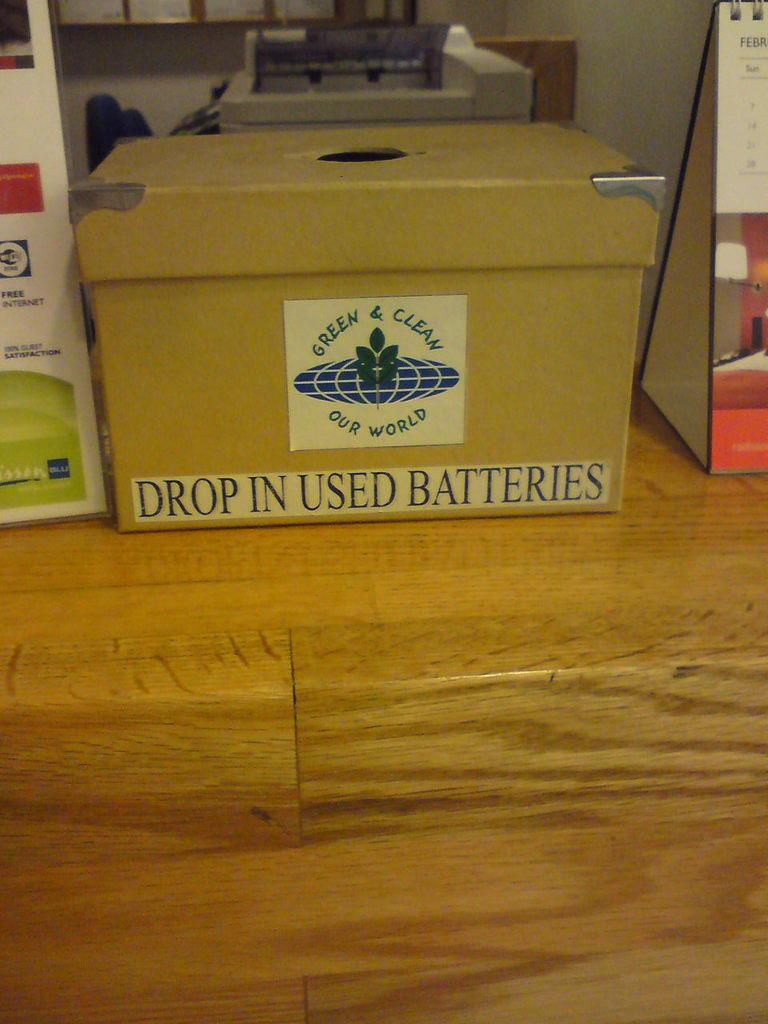<image>
Create a compact narrative representing the image presented. A box with an opening on top is labeled as a place to drop used batteries. 